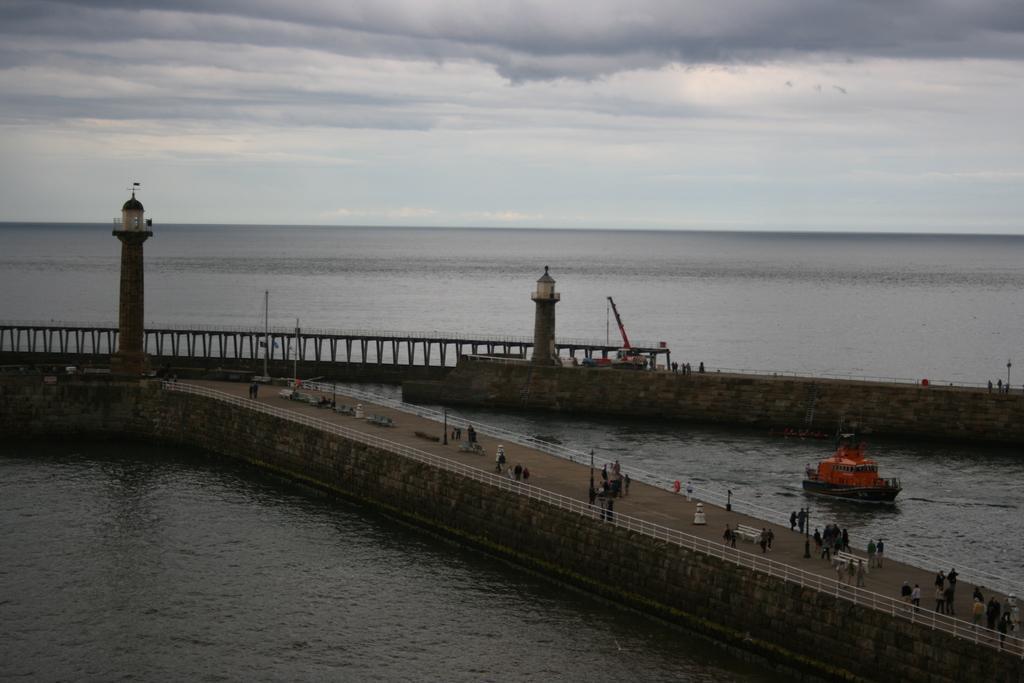Could you give a brief overview of what you see in this image? In this picture there is water on the right and left side of the image and there is dock in the center of the image, there are two pillars on the right and left side of the image. 